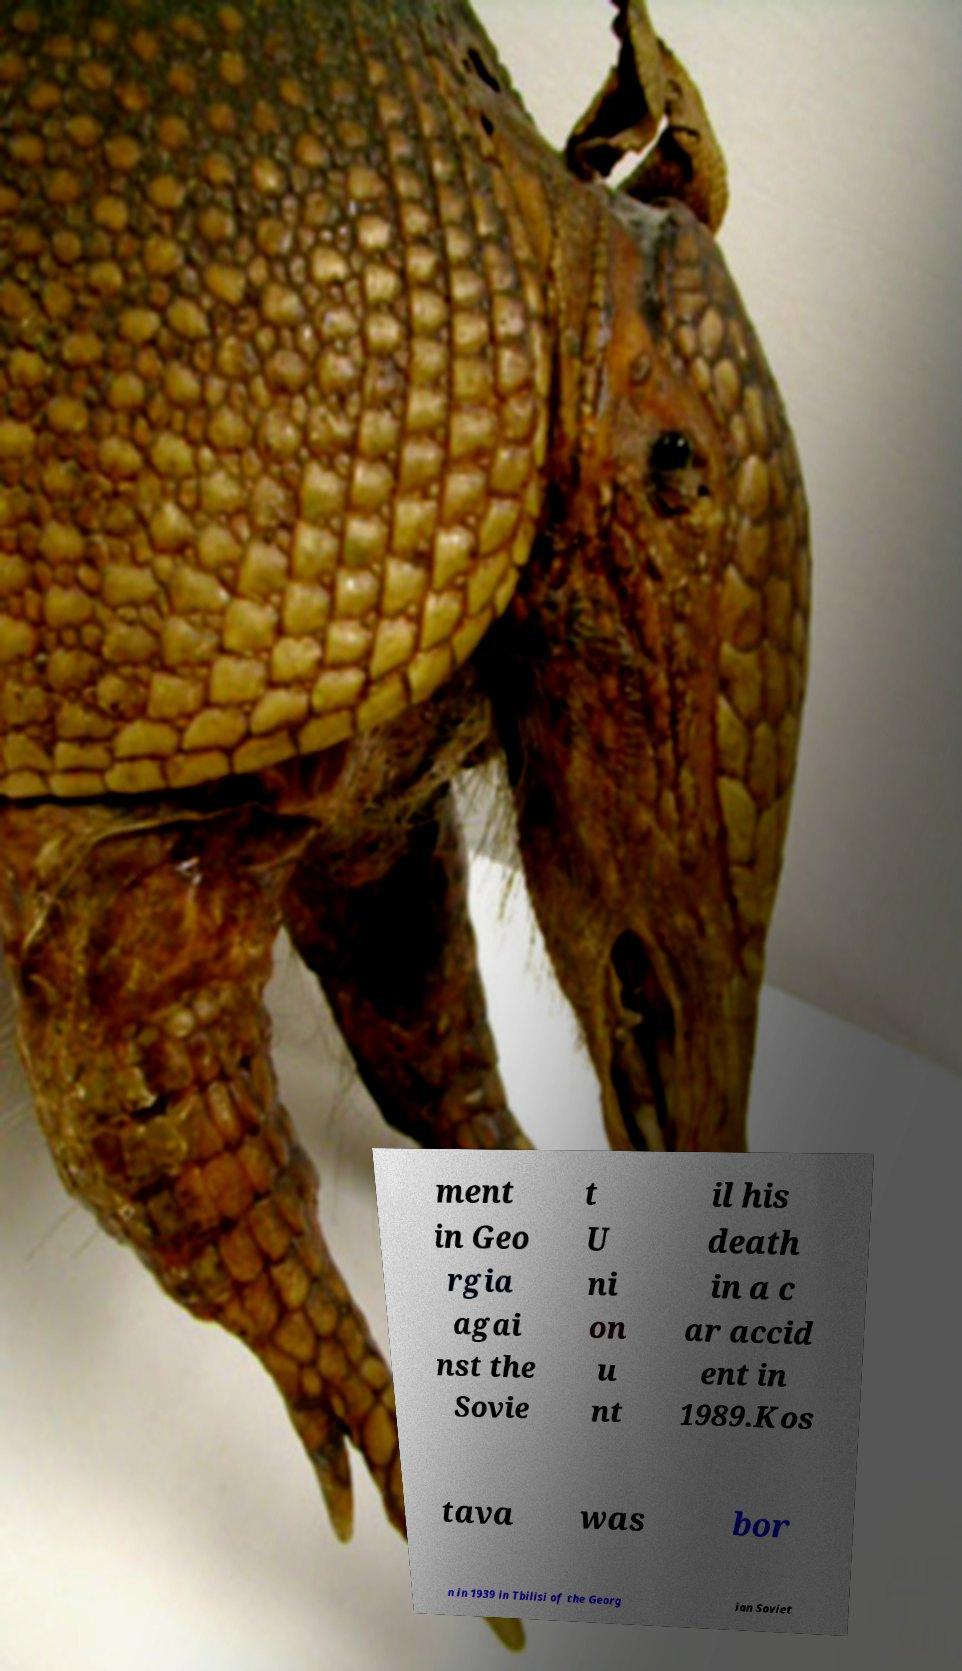Could you extract and type out the text from this image? ment in Geo rgia agai nst the Sovie t U ni on u nt il his death in a c ar accid ent in 1989.Kos tava was bor n in 1939 in Tbilisi of the Georg ian Soviet 